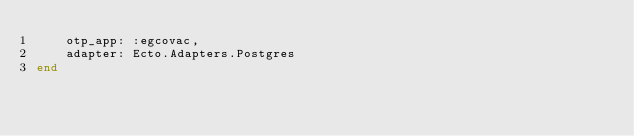<code> <loc_0><loc_0><loc_500><loc_500><_Elixir_>    otp_app: :egcovac,
    adapter: Ecto.Adapters.Postgres
end
</code> 